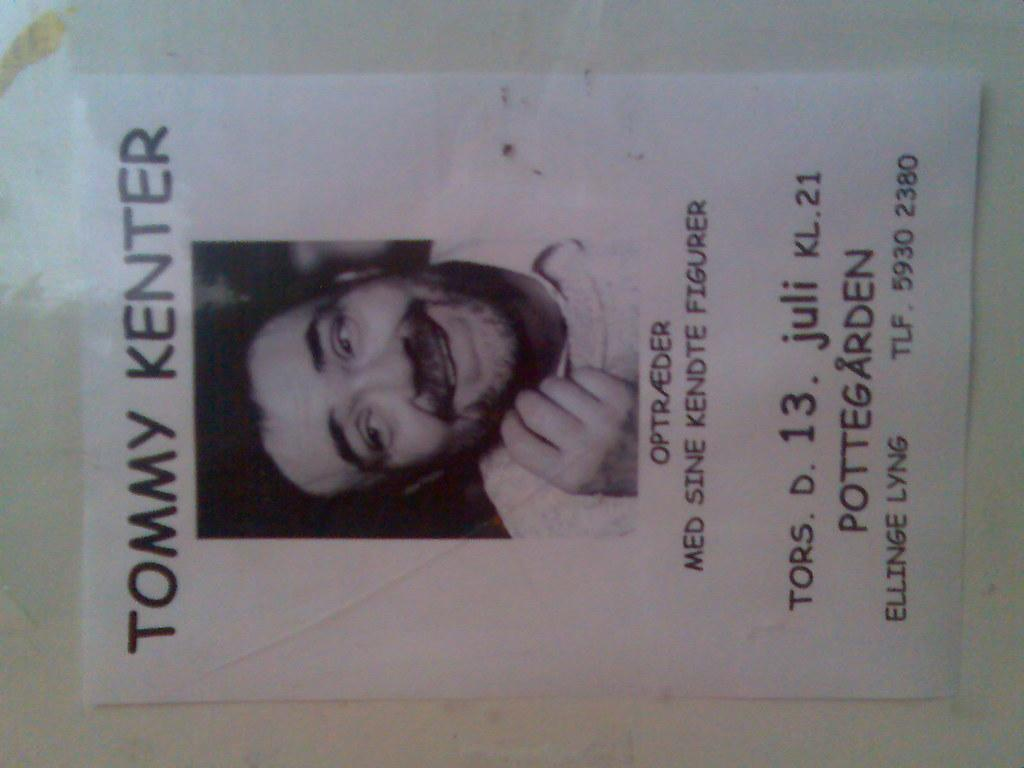<image>
Provide a brief description of the given image. A poster for Tommy Kenter hangs from a white wall 